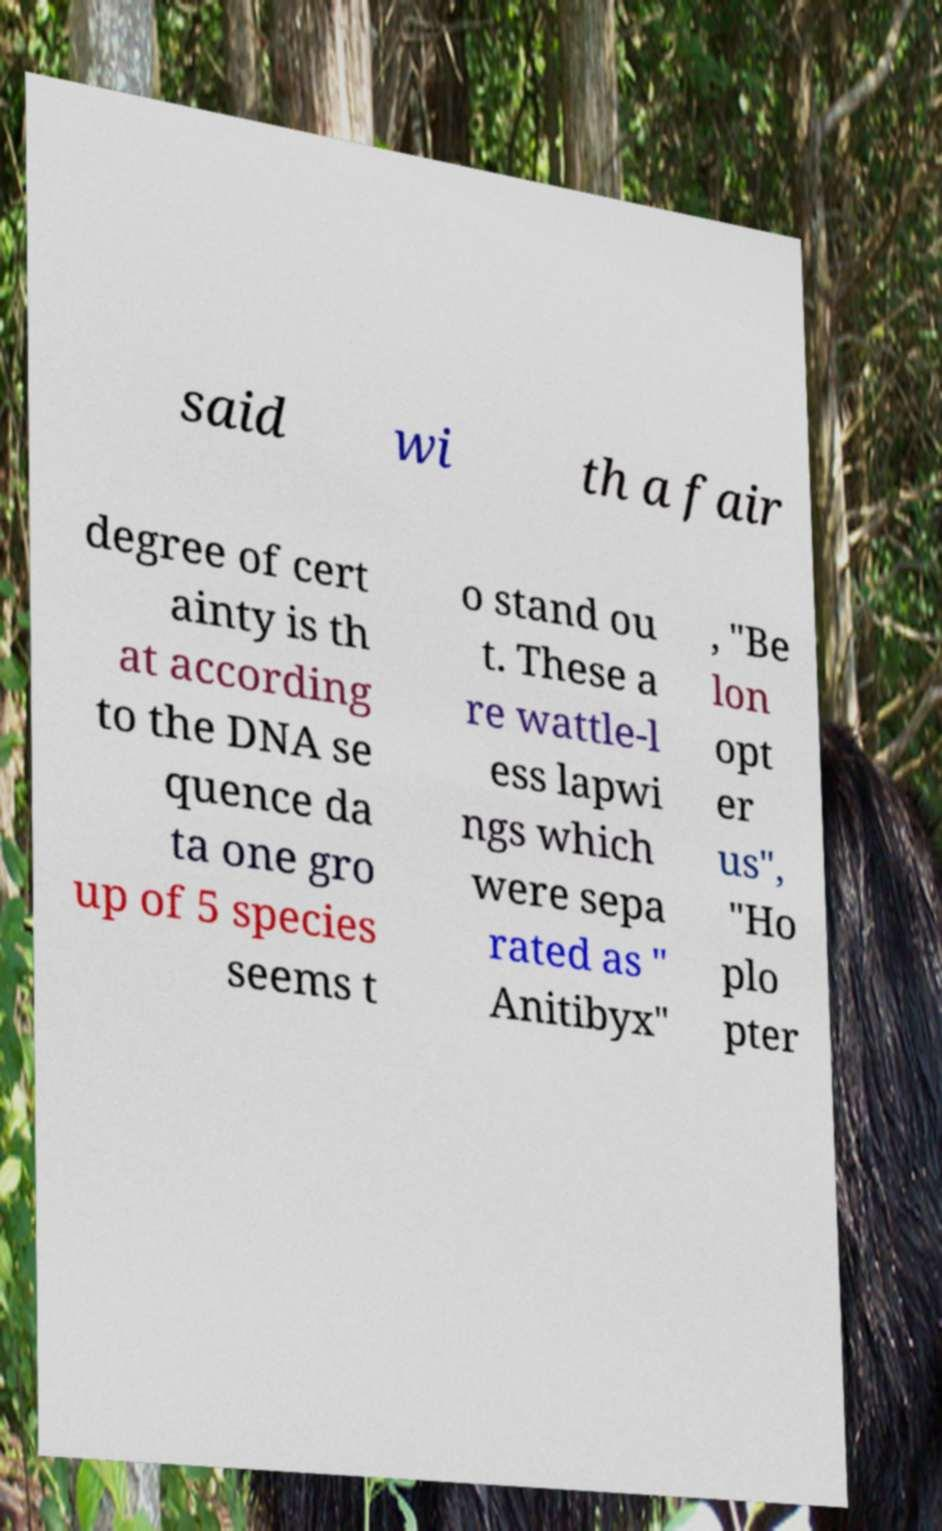Could you extract and type out the text from this image? said wi th a fair degree of cert ainty is th at according to the DNA se quence da ta one gro up of 5 species seems t o stand ou t. These a re wattle-l ess lapwi ngs which were sepa rated as " Anitibyx" , "Be lon opt er us", "Ho plo pter 